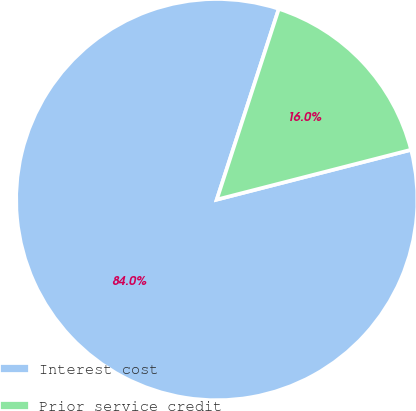<chart> <loc_0><loc_0><loc_500><loc_500><pie_chart><fcel>Interest cost<fcel>Prior service credit<nl><fcel>84.0%<fcel>16.0%<nl></chart> 